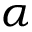<formula> <loc_0><loc_0><loc_500><loc_500>\alpha</formula> 